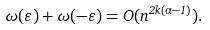Convert formula to latex. <formula><loc_0><loc_0><loc_500><loc_500>\omega ( \varepsilon ) + \omega ( - \varepsilon ) = O ( n ^ { 2 k ( \alpha - 1 ) } ) .</formula> 